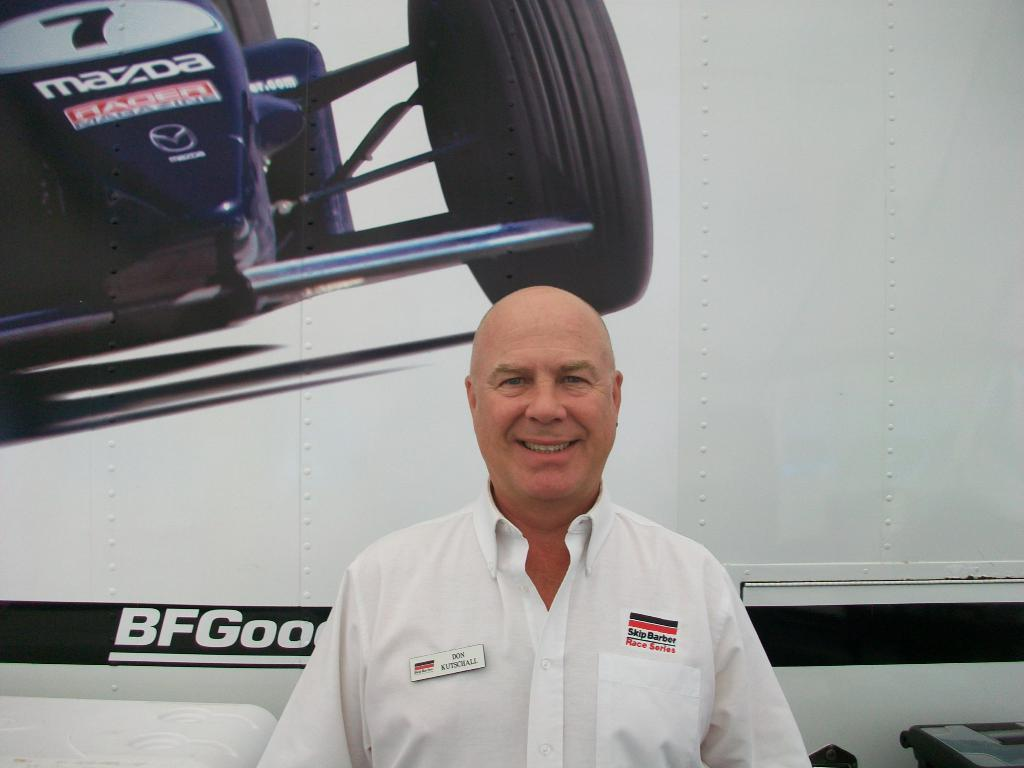<image>
Relay a brief, clear account of the picture shown. A man in a white shirt standing in front of a BFGood sign and a racer by Mazda 